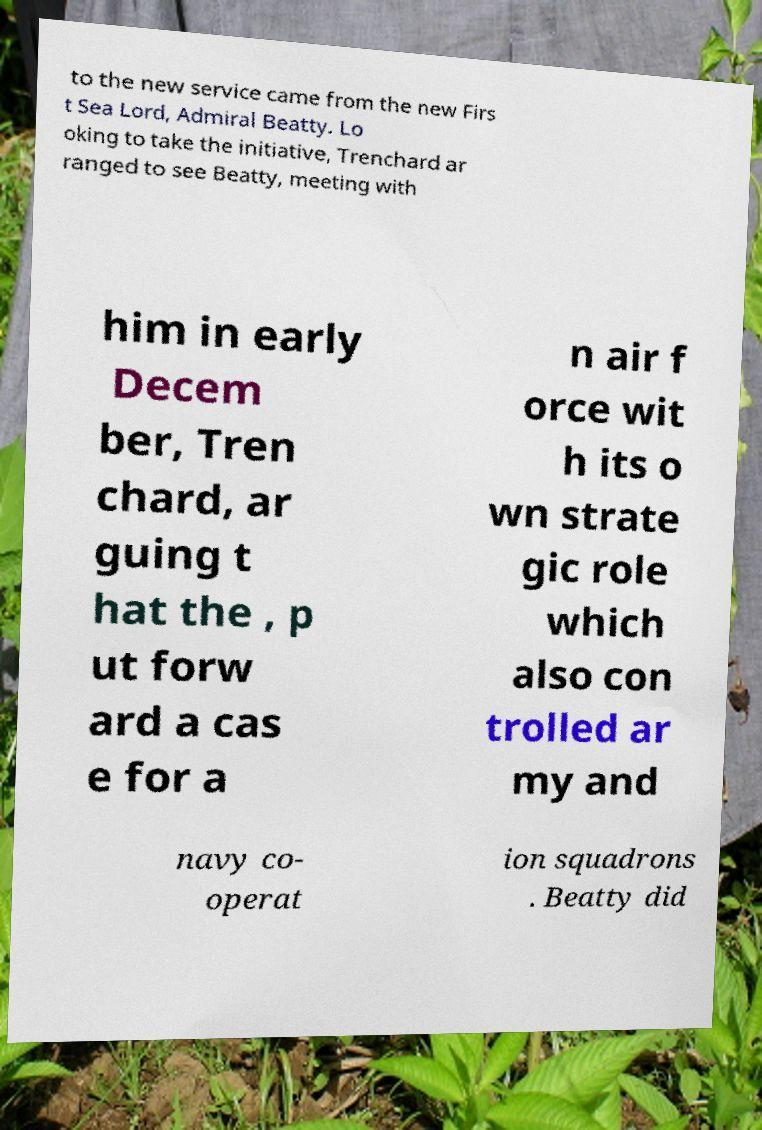There's text embedded in this image that I need extracted. Can you transcribe it verbatim? to the new service came from the new Firs t Sea Lord, Admiral Beatty. Lo oking to take the initiative, Trenchard ar ranged to see Beatty, meeting with him in early Decem ber, Tren chard, ar guing t hat the , p ut forw ard a cas e for a n air f orce wit h its o wn strate gic role which also con trolled ar my and navy co- operat ion squadrons . Beatty did 